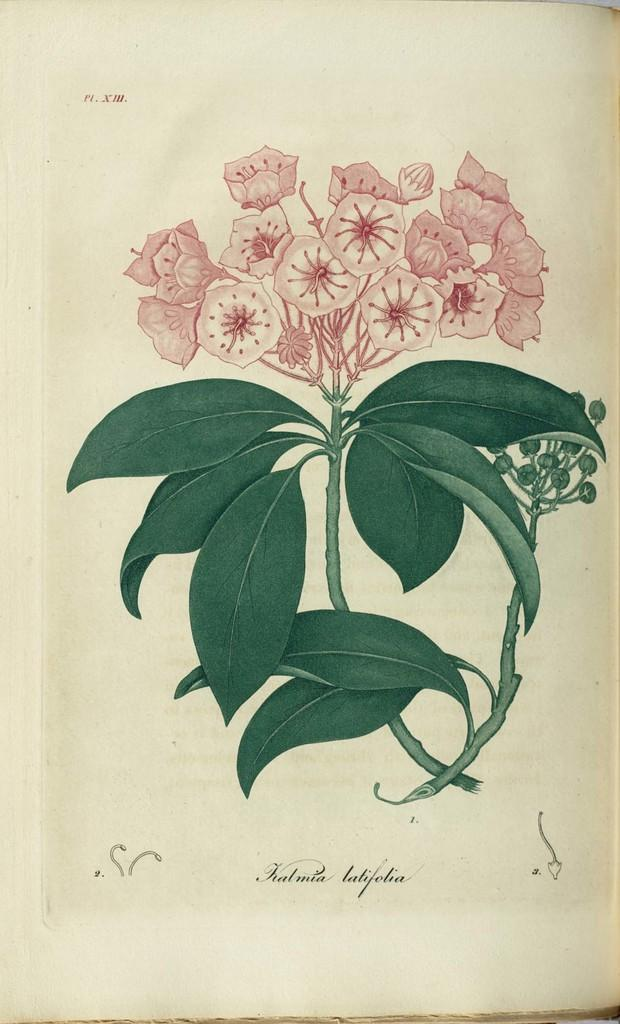What is the main subject of the image? The main subject of the image is a drawing of a plant. What colors are present in the plant's drawing? The plant has green leaves and pink flowers. Is there any text in the image? Yes, there is text at the bottom of the image. How many houses are visible in the image? There are no houses present in the image; it features a drawing of a plant with text at the bottom. Can you tell me how many wishes are granted to the horses in the image? There are no horses present in the image, and therefore no wishes can be granted to them. 